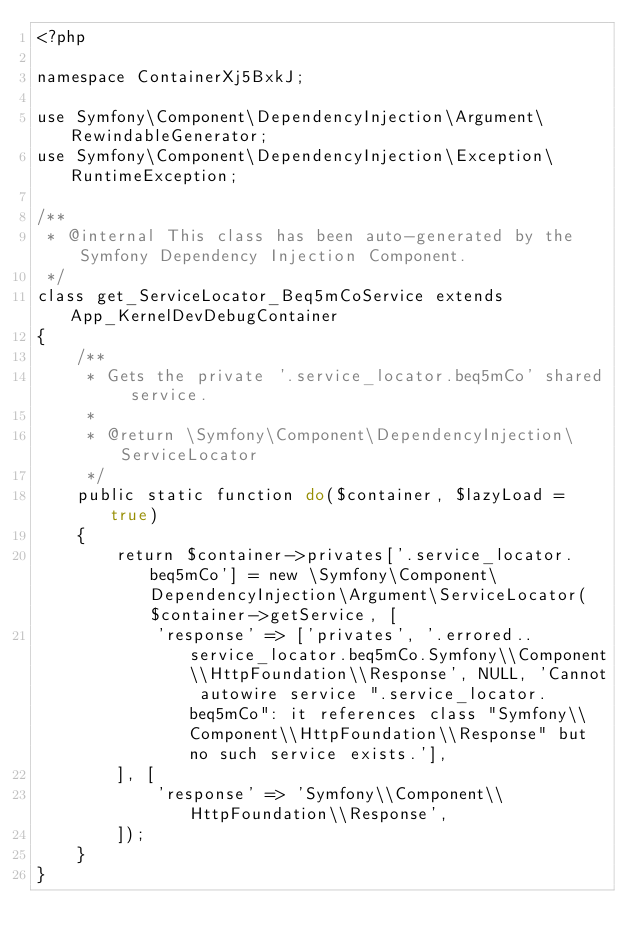Convert code to text. <code><loc_0><loc_0><loc_500><loc_500><_PHP_><?php

namespace ContainerXj5BxkJ;

use Symfony\Component\DependencyInjection\Argument\RewindableGenerator;
use Symfony\Component\DependencyInjection\Exception\RuntimeException;

/**
 * @internal This class has been auto-generated by the Symfony Dependency Injection Component.
 */
class get_ServiceLocator_Beq5mCoService extends App_KernelDevDebugContainer
{
    /**
     * Gets the private '.service_locator.beq5mCo' shared service.
     *
     * @return \Symfony\Component\DependencyInjection\ServiceLocator
     */
    public static function do($container, $lazyLoad = true)
    {
        return $container->privates['.service_locator.beq5mCo'] = new \Symfony\Component\DependencyInjection\Argument\ServiceLocator($container->getService, [
            'response' => ['privates', '.errored..service_locator.beq5mCo.Symfony\\Component\\HttpFoundation\\Response', NULL, 'Cannot autowire service ".service_locator.beq5mCo": it references class "Symfony\\Component\\HttpFoundation\\Response" but no such service exists.'],
        ], [
            'response' => 'Symfony\\Component\\HttpFoundation\\Response',
        ]);
    }
}
</code> 